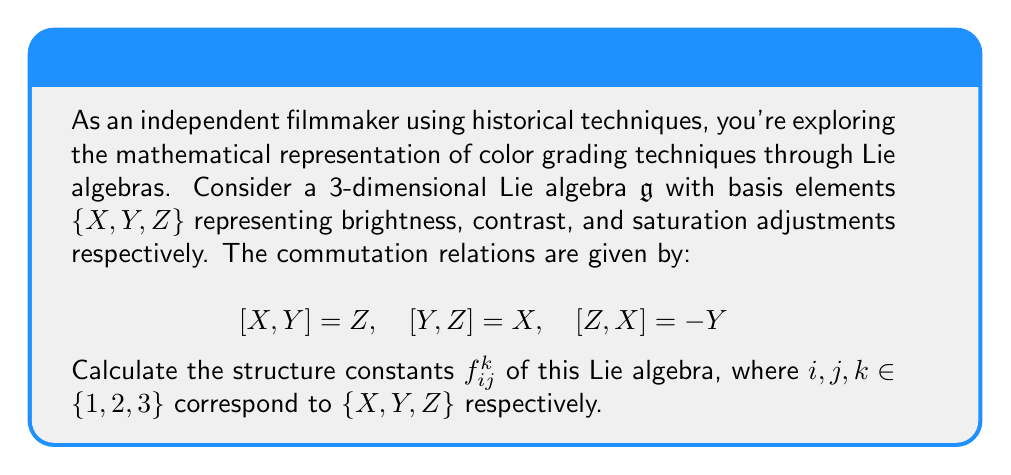Can you answer this question? To calculate the structure constants, we follow these steps:

1) Recall that structure constants are defined by the equation:
   $$[e_i, e_j] = \sum_{k=1}^3 f_{ij}^k e_k$$
   where $e_1 = X$, $e_2 = Y$, and $e_3 = Z$.

2) From the given commutation relations, we can identify:
   - $[X, Y] = Z$ implies $f_{12}^3 = 1$
   - $[Y, Z] = X$ implies $f_{23}^1 = 1$
   - $[Z, X] = -Y$ implies $f_{31}^2 = -1$

3) Note that $f_{ij}^k = -f_{ji}^k$ due to the antisymmetry of the Lie bracket. So:
   - $f_{21}^3 = -1$
   - $f_{32}^1 = -1$
   - $f_{13}^2 = 1$

4) All other structure constants are zero.

5) We can represent these structure constants in a 3x3x3 array:

   For $k=1$: $\begin{pmatrix}
   0 & 0 & -1 \\
   0 & 0 & 1 \\
   1 & -1 & 0
   \end{pmatrix}$

   For $k=2$: $\begin{pmatrix}
   0 & 0 & 1 \\
   0 & 0 & 0 \\
   -1 & 0 & 0
   \end{pmatrix}$

   For $k=3$: $\begin{pmatrix}
   0 & 1 & 0 \\
   -1 & 0 & 0 \\
   0 & 0 & 0
   \end{pmatrix}$

This representation of color grading techniques as a Lie algebra allows for a mathematical analysis of how different adjustments interact and compose, which could be useful in developing historically-inspired color grading algorithms for filmmaking.
Answer: $f_{12}^3 = f_{23}^1 = f_{31}^2 = -f_{21}^3 = -f_{32}^1 = -f_{13}^2 = 1$, all others zero. 